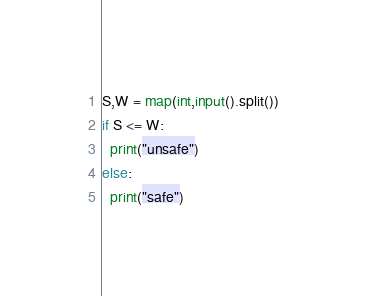<code> <loc_0><loc_0><loc_500><loc_500><_Python_>S,W = map(int,input().split())
if S <= W:
  print("unsafe")
else:
  print("safe")</code> 